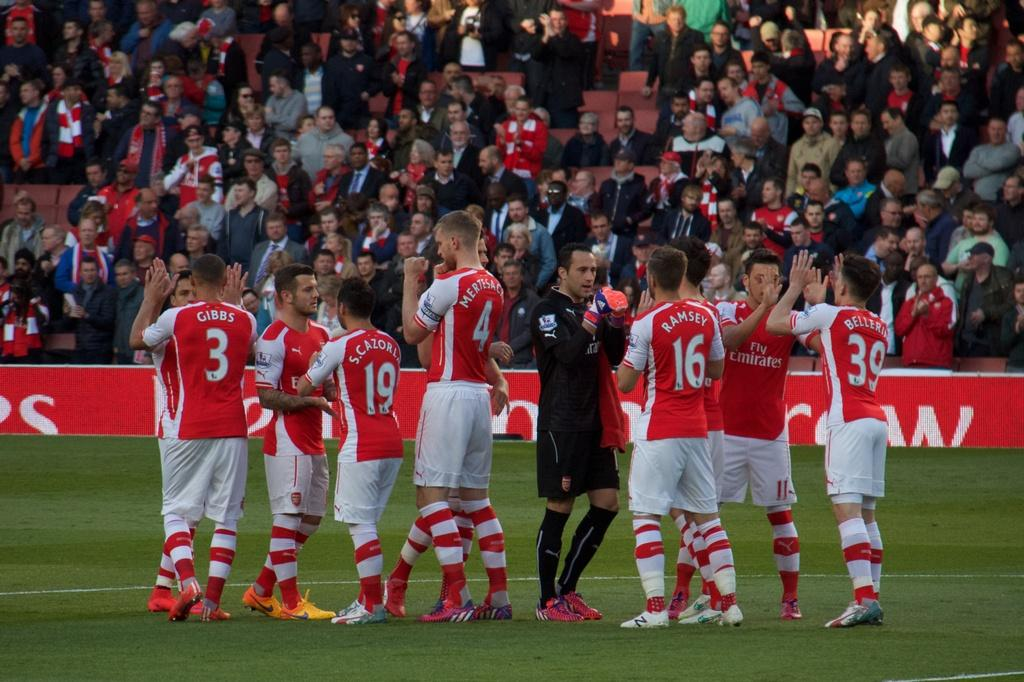<image>
Relay a brief, clear account of the picture shown. A player with a 16 on his jersey is on a field with other players. 